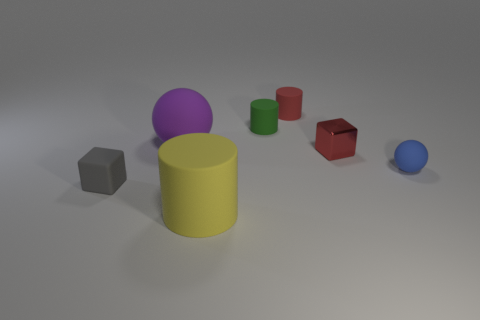Are there more blue matte objects that are in front of the small blue sphere than yellow cylinders? After closely examining the image, it appears there are no blue matte objects in front of the small blue sphere; the objects in front are of different colors. Therefore, there cannot be more blue matte objects than yellow cylinders in that specific area. 